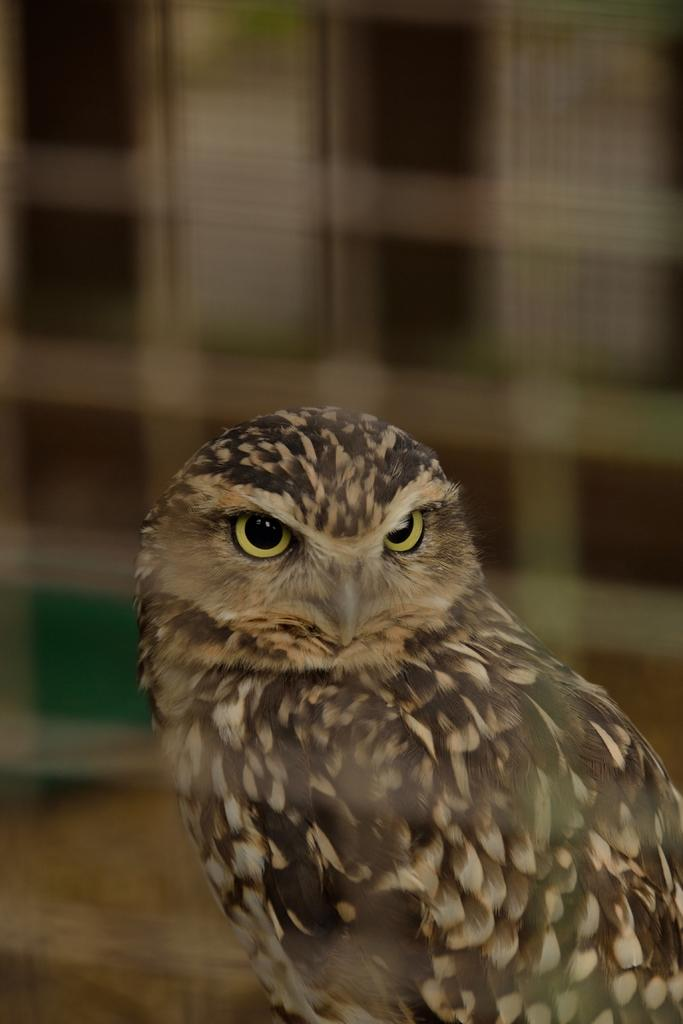What type of animal is in the image? There is an owl in the image. What type of advice does the owl give to the porter in the image? There is no porter or advice present in the image; it only features an owl. 